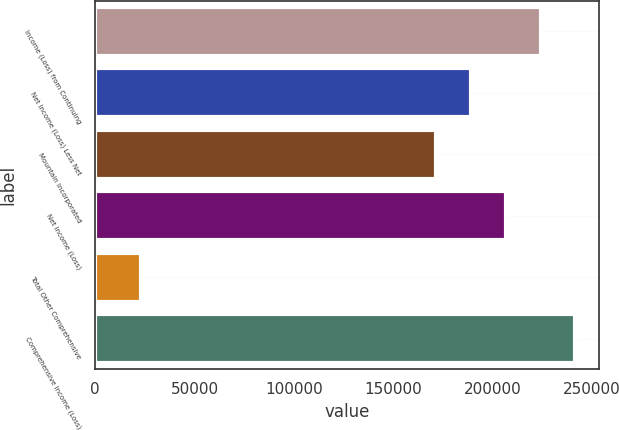<chart> <loc_0><loc_0><loc_500><loc_500><bar_chart><fcel>Income (Loss) from Continuing<fcel>Net Income (Loss) Less Net<fcel>Mountain Incorporated<fcel>Net Income (Loss)<fcel>Total Other Comprehensive<fcel>Comprehensive Income (Loss)<nl><fcel>224158<fcel>189191<fcel>171708<fcel>206675<fcel>23186<fcel>241642<nl></chart> 